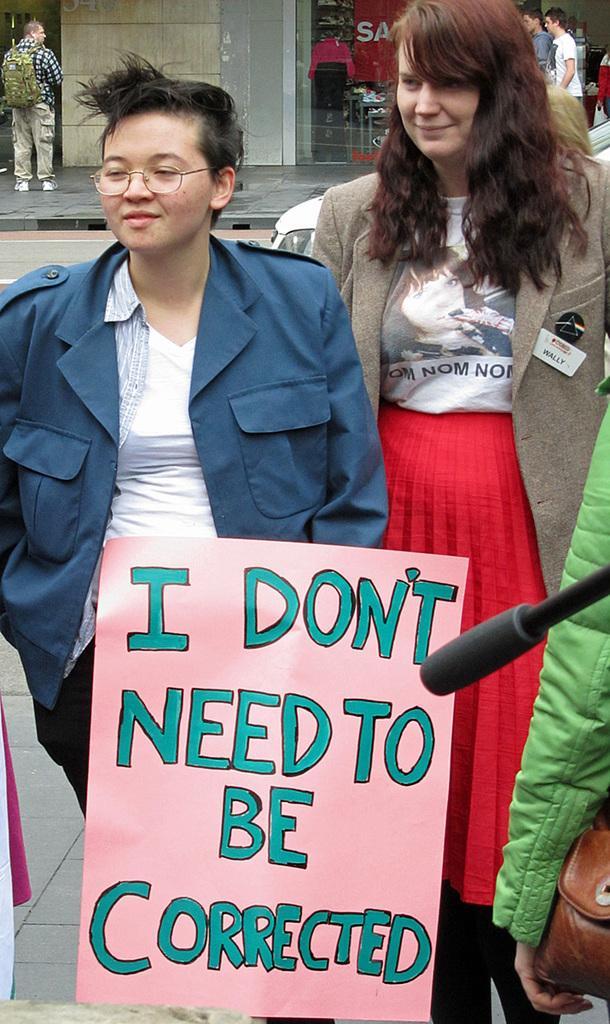Please provide a concise description of this image. In this image we can see two women smiling and standing on the ground. In the center there is a text on the paper. We can also see the mike. In the background we can also see few persons. 